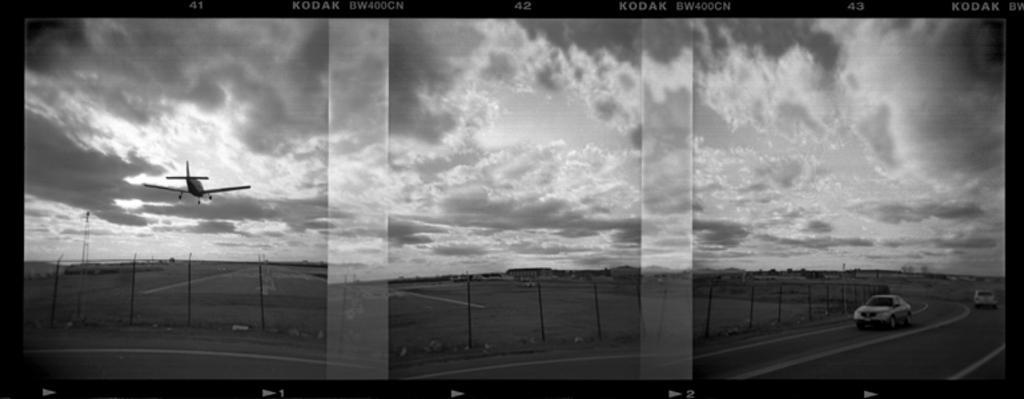<image>
Summarize the visual content of the image. An image of the countryiside in grayscale made with KODAK film 